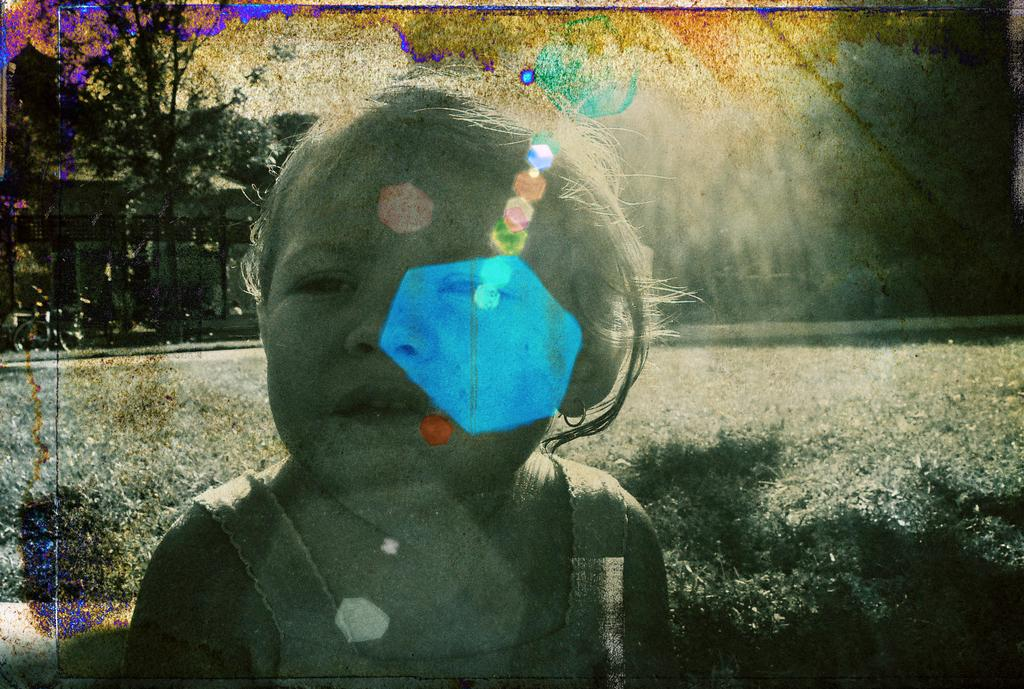What type of vegetation is present in the image? There is grass in the image. Can you describe the child in the image? There is a child standing in the front of the image. What can be seen in the background of the image? There are trees in the background of the image. What type of songs can be heard in the background of the image? There is no audio or indication of songs in the image. Can you spot a snake in the image? There is no snake present in the image. 